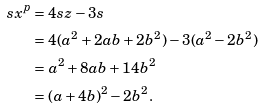<formula> <loc_0><loc_0><loc_500><loc_500>s x ^ { p } & = 4 s z - 3 s \\ & = 4 ( a ^ { 2 } + 2 a b + 2 b ^ { 2 } ) - 3 ( a ^ { 2 } - 2 b ^ { 2 } ) \\ & = a ^ { 2 } + 8 a b + 1 4 b ^ { 2 } \\ & = ( a + 4 b ) ^ { 2 } - 2 b ^ { 2 } .</formula> 